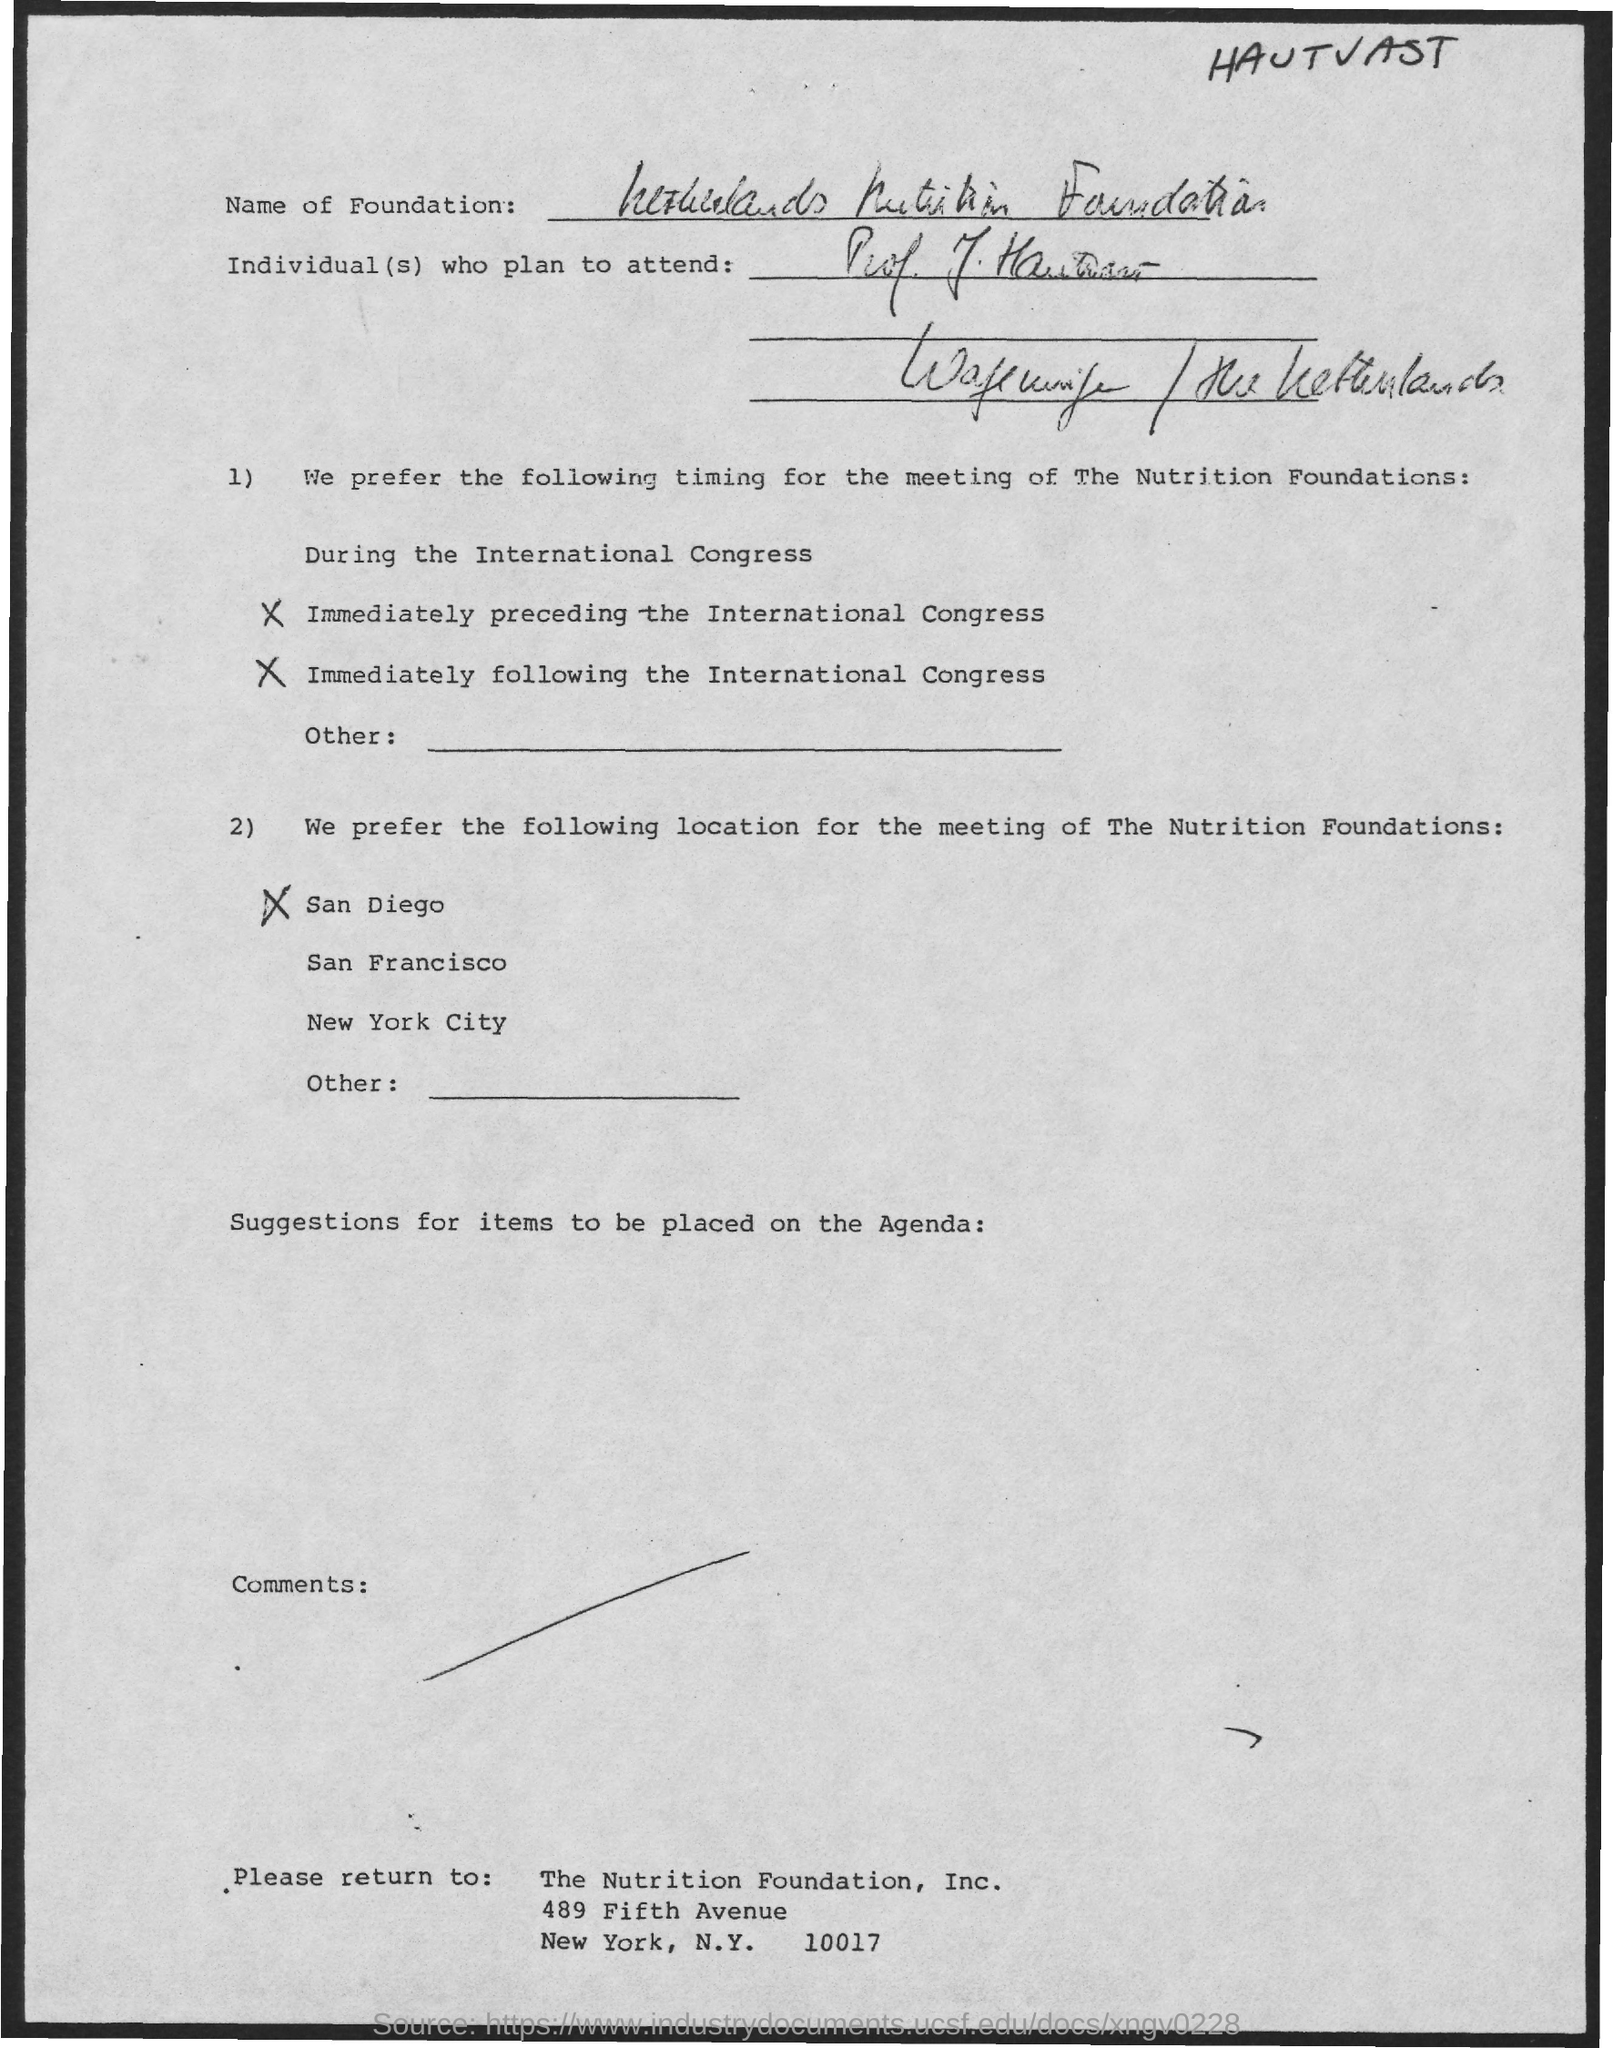List a handful of essential elements in this visual. This letter is addressed to the Nutrition Foundation, INC. The Nutrition Foundation, Inc. is located in New York City. 